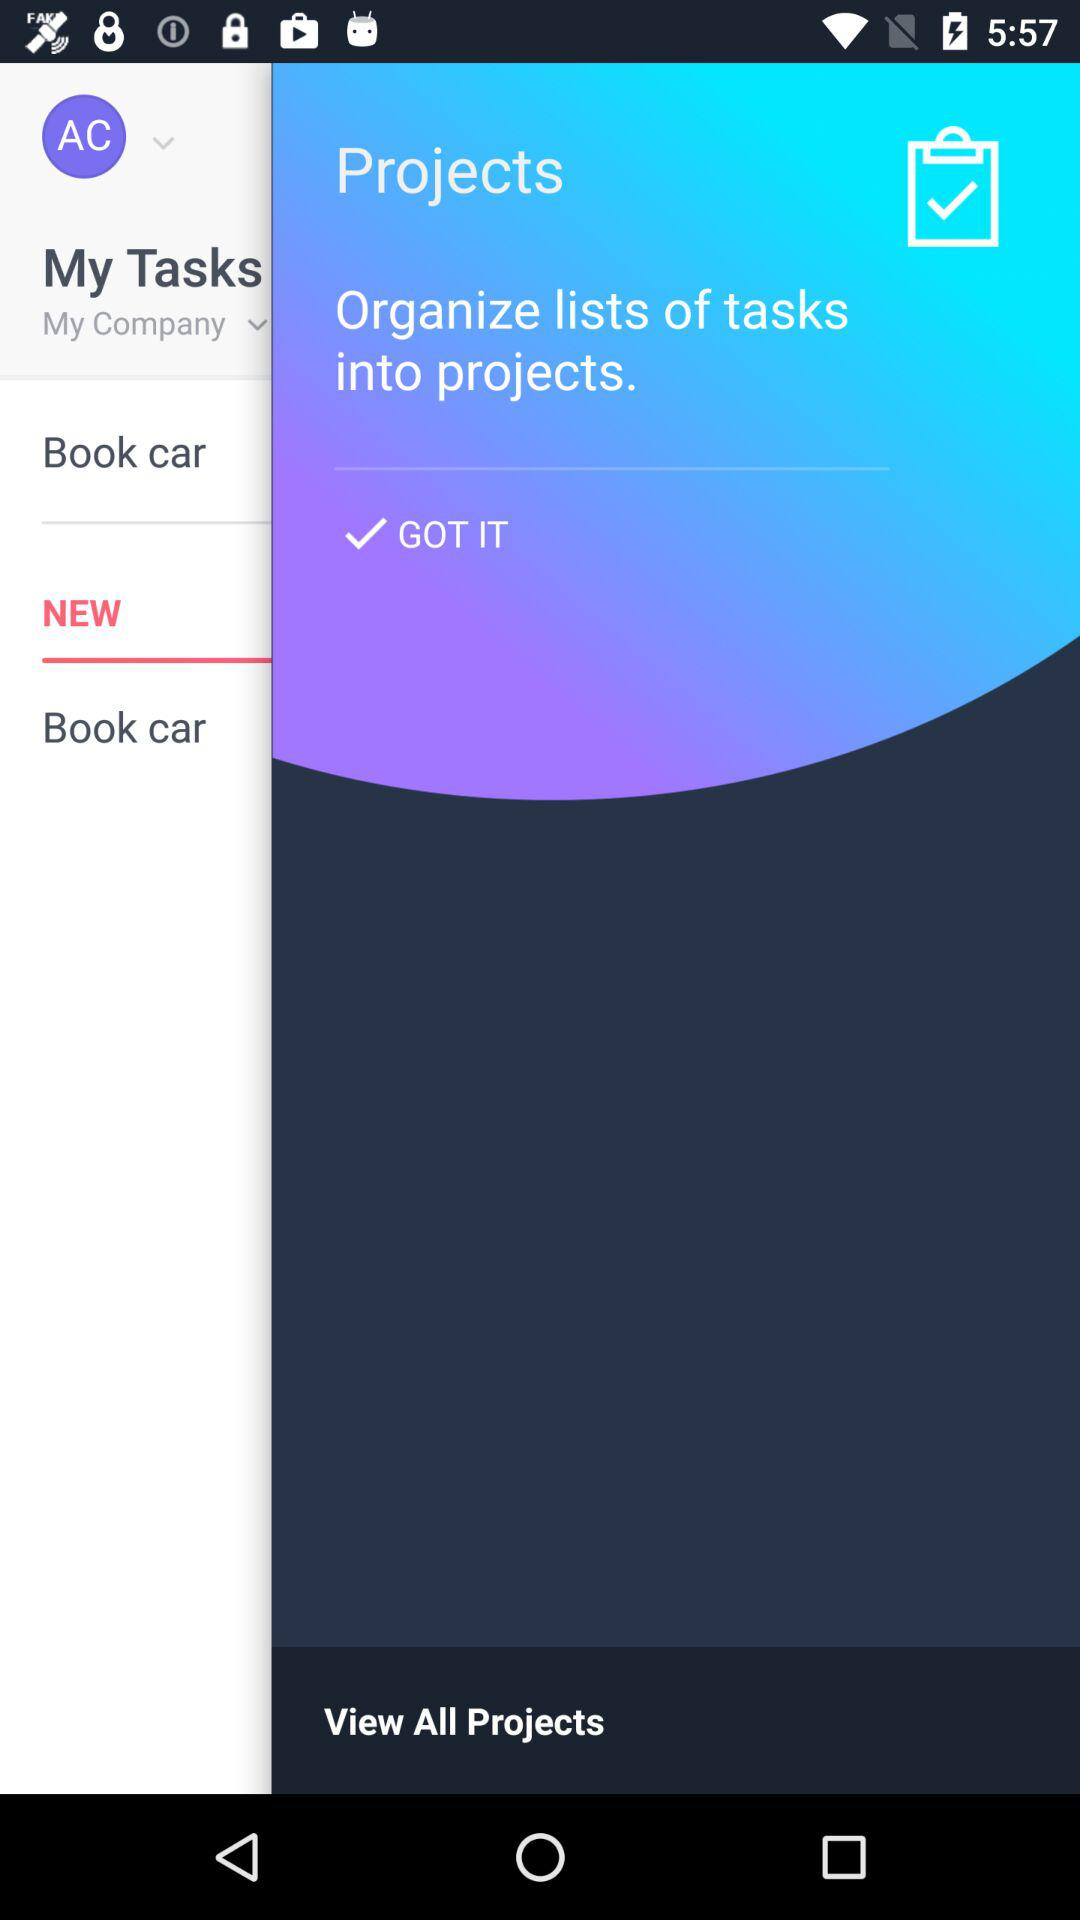What is the username?
When the provided information is insufficient, respond with <no answer>. <no answer> 